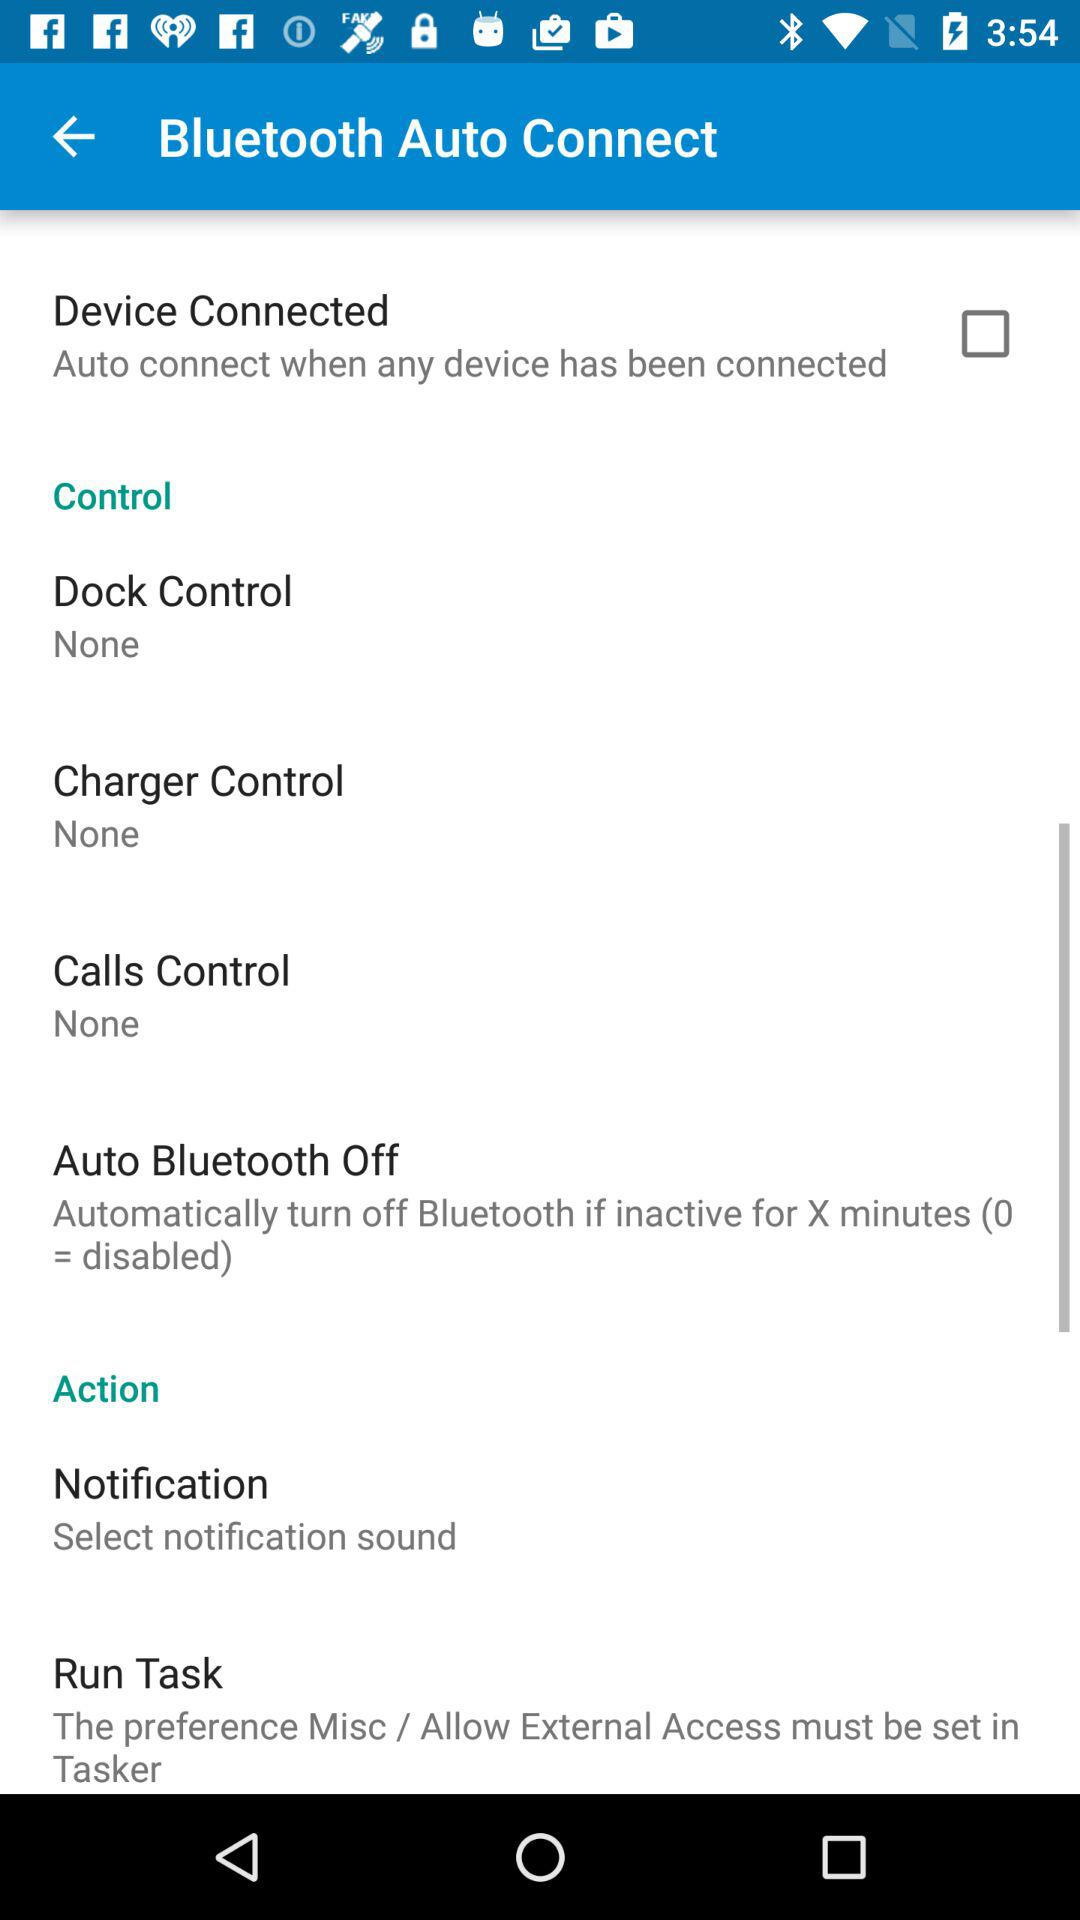What is the setting for "Dock Control"? The setting is "None". 